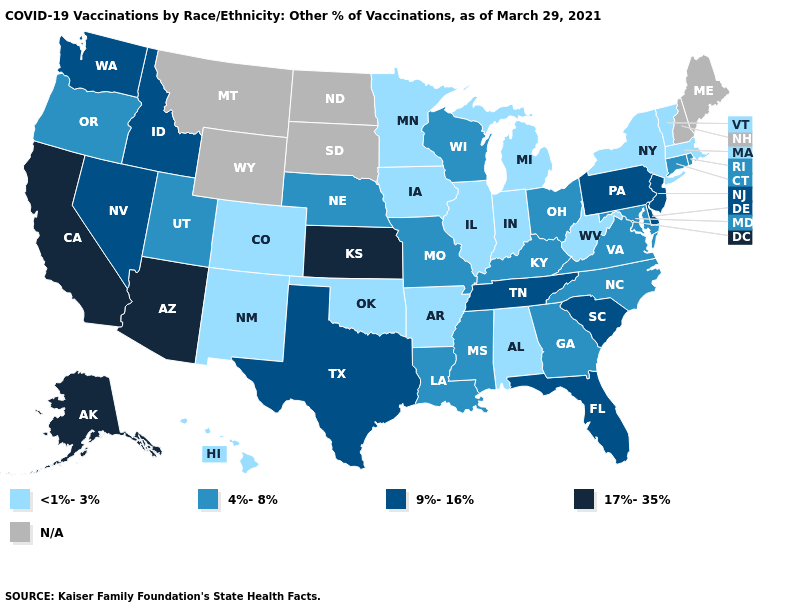Name the states that have a value in the range <1%-3%?
Short answer required. Alabama, Arkansas, Colorado, Hawaii, Illinois, Indiana, Iowa, Massachusetts, Michigan, Minnesota, New Mexico, New York, Oklahoma, Vermont, West Virginia. Name the states that have a value in the range <1%-3%?
Answer briefly. Alabama, Arkansas, Colorado, Hawaii, Illinois, Indiana, Iowa, Massachusetts, Michigan, Minnesota, New Mexico, New York, Oklahoma, Vermont, West Virginia. Which states have the highest value in the USA?
Write a very short answer. Alaska, Arizona, California, Kansas. Which states have the lowest value in the MidWest?
Be succinct. Illinois, Indiana, Iowa, Michigan, Minnesota. What is the value of Kansas?
Keep it brief. 17%-35%. What is the value of South Carolina?
Write a very short answer. 9%-16%. Name the states that have a value in the range <1%-3%?
Answer briefly. Alabama, Arkansas, Colorado, Hawaii, Illinois, Indiana, Iowa, Massachusetts, Michigan, Minnesota, New Mexico, New York, Oklahoma, Vermont, West Virginia. Name the states that have a value in the range 17%-35%?
Short answer required. Alaska, Arizona, California, Kansas. Among the states that border New Hampshire , which have the highest value?
Concise answer only. Massachusetts, Vermont. Does Rhode Island have the lowest value in the Northeast?
Concise answer only. No. Is the legend a continuous bar?
Keep it brief. No. What is the value of Colorado?
Answer briefly. <1%-3%. What is the lowest value in the USA?
Give a very brief answer. <1%-3%. Which states have the lowest value in the South?
Be succinct. Alabama, Arkansas, Oklahoma, West Virginia. Name the states that have a value in the range 9%-16%?
Write a very short answer. Delaware, Florida, Idaho, Nevada, New Jersey, Pennsylvania, South Carolina, Tennessee, Texas, Washington. 